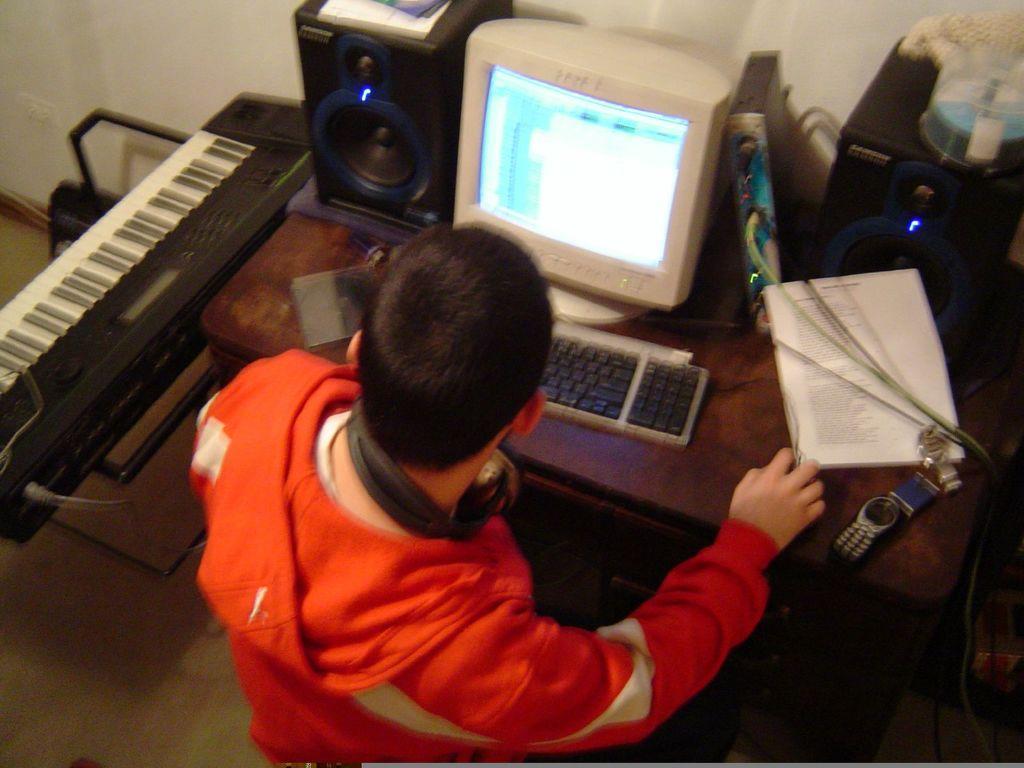In one or two sentences, can you explain what this image depicts? In this image I can see a man in yellow hoodie. I can also see he is wearing a headphone. On this table I can see a speaker, monitor, keyboard and few more items. Here I can see a keyboard. 